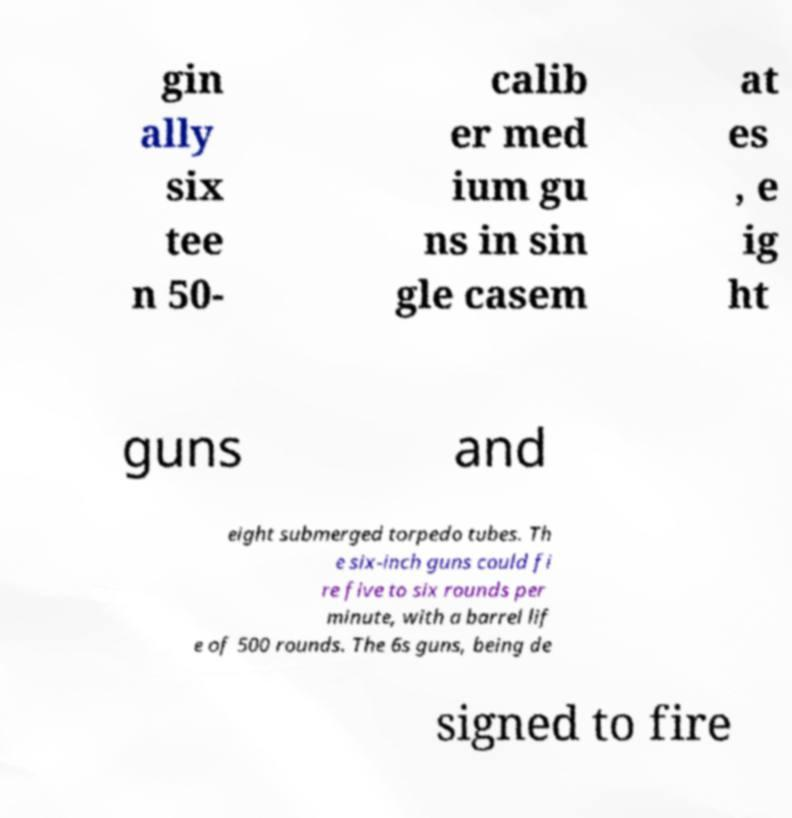Could you assist in decoding the text presented in this image and type it out clearly? gin ally six tee n 50- calib er med ium gu ns in sin gle casem at es , e ig ht guns and eight submerged torpedo tubes. Th e six-inch guns could fi re five to six rounds per minute, with a barrel lif e of 500 rounds. The 6s guns, being de signed to fire 